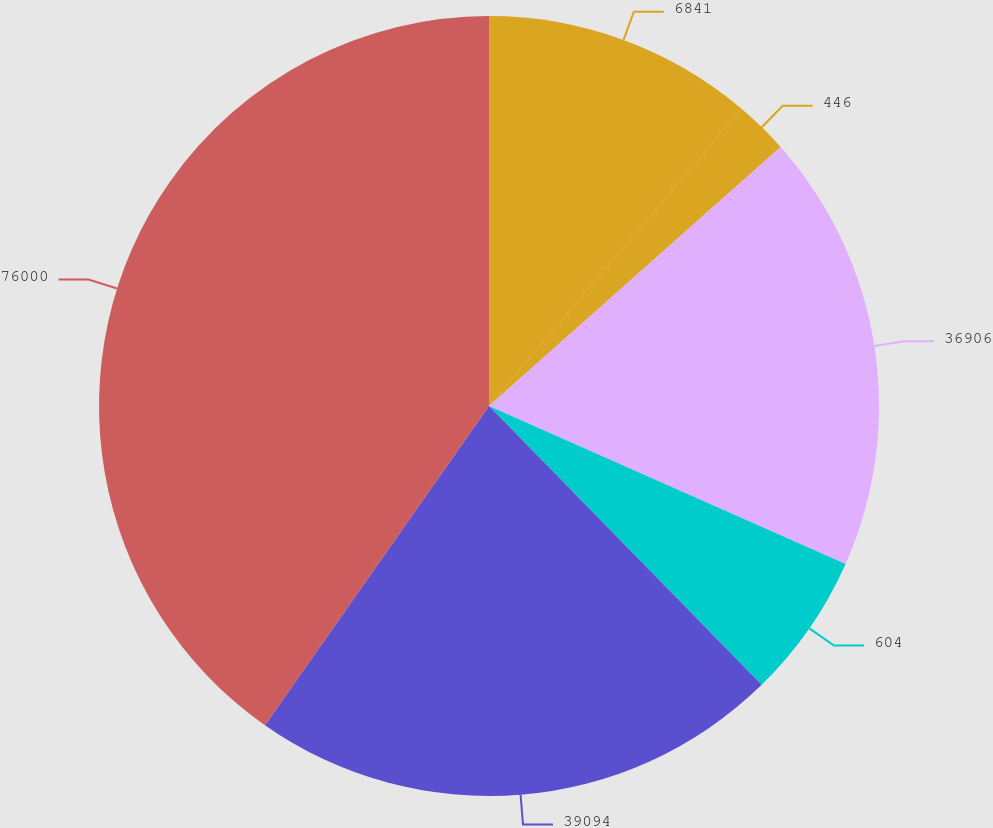Convert chart to OTSL. <chart><loc_0><loc_0><loc_500><loc_500><pie_chart><fcel>6841<fcel>446<fcel>36906<fcel>604<fcel>39094<fcel>76000<nl><fcel>11.21%<fcel>2.23%<fcel>18.2%<fcel>6.04%<fcel>22.06%<fcel>40.26%<nl></chart> 